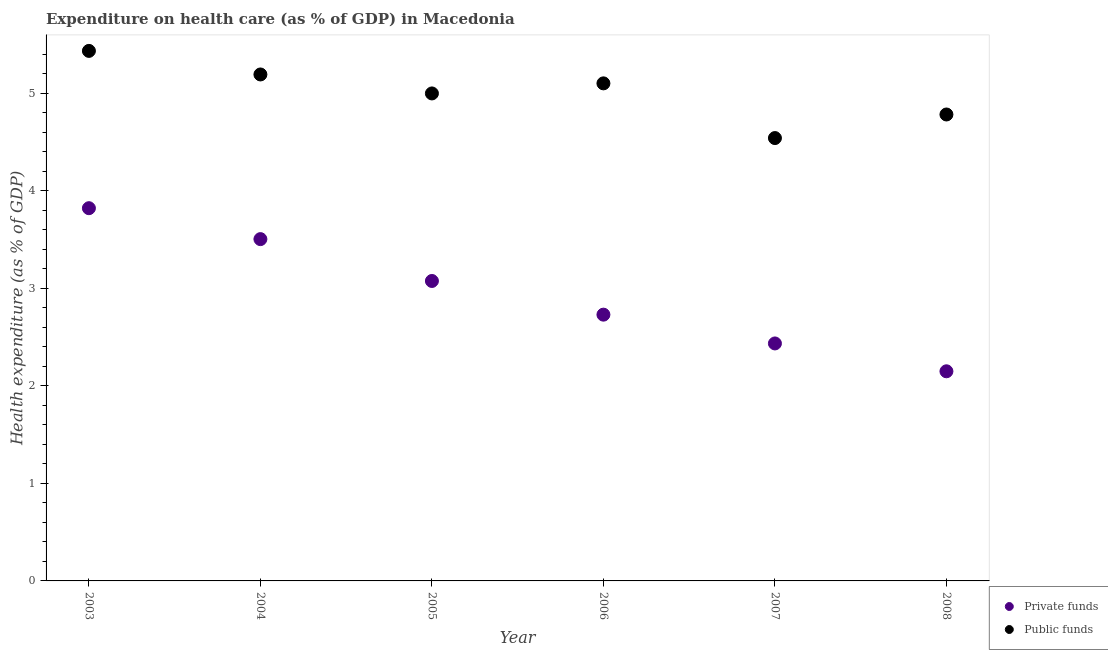Is the number of dotlines equal to the number of legend labels?
Keep it short and to the point. Yes. What is the amount of public funds spent in healthcare in 2003?
Your answer should be compact. 5.43. Across all years, what is the maximum amount of private funds spent in healthcare?
Your answer should be compact. 3.82. Across all years, what is the minimum amount of private funds spent in healthcare?
Your answer should be very brief. 2.15. What is the total amount of private funds spent in healthcare in the graph?
Your response must be concise. 17.72. What is the difference between the amount of public funds spent in healthcare in 2006 and that in 2008?
Offer a very short reply. 0.32. What is the difference between the amount of private funds spent in healthcare in 2003 and the amount of public funds spent in healthcare in 2005?
Your answer should be very brief. -1.18. What is the average amount of public funds spent in healthcare per year?
Give a very brief answer. 5.01. In the year 2003, what is the difference between the amount of private funds spent in healthcare and amount of public funds spent in healthcare?
Make the answer very short. -1.61. In how many years, is the amount of public funds spent in healthcare greater than 2.2 %?
Your answer should be compact. 6. What is the ratio of the amount of public funds spent in healthcare in 2003 to that in 2005?
Offer a very short reply. 1.09. Is the amount of private funds spent in healthcare in 2003 less than that in 2008?
Make the answer very short. No. Is the difference between the amount of private funds spent in healthcare in 2004 and 2005 greater than the difference between the amount of public funds spent in healthcare in 2004 and 2005?
Keep it short and to the point. Yes. What is the difference between the highest and the second highest amount of public funds spent in healthcare?
Give a very brief answer. 0.24. What is the difference between the highest and the lowest amount of private funds spent in healthcare?
Provide a short and direct response. 1.67. Is the amount of public funds spent in healthcare strictly greater than the amount of private funds spent in healthcare over the years?
Keep it short and to the point. Yes. What is the difference between two consecutive major ticks on the Y-axis?
Your answer should be compact. 1. Are the values on the major ticks of Y-axis written in scientific E-notation?
Make the answer very short. No. Does the graph contain any zero values?
Provide a short and direct response. No. How many legend labels are there?
Keep it short and to the point. 2. How are the legend labels stacked?
Your response must be concise. Vertical. What is the title of the graph?
Provide a succinct answer. Expenditure on health care (as % of GDP) in Macedonia. Does "Male labourers" appear as one of the legend labels in the graph?
Give a very brief answer. No. What is the label or title of the Y-axis?
Offer a terse response. Health expenditure (as % of GDP). What is the Health expenditure (as % of GDP) of Private funds in 2003?
Your answer should be very brief. 3.82. What is the Health expenditure (as % of GDP) in Public funds in 2003?
Provide a short and direct response. 5.43. What is the Health expenditure (as % of GDP) of Private funds in 2004?
Your response must be concise. 3.5. What is the Health expenditure (as % of GDP) in Public funds in 2004?
Offer a very short reply. 5.19. What is the Health expenditure (as % of GDP) of Private funds in 2005?
Offer a very short reply. 3.08. What is the Health expenditure (as % of GDP) of Public funds in 2005?
Offer a very short reply. 5. What is the Health expenditure (as % of GDP) in Private funds in 2006?
Provide a short and direct response. 2.73. What is the Health expenditure (as % of GDP) in Public funds in 2006?
Give a very brief answer. 5.1. What is the Health expenditure (as % of GDP) in Private funds in 2007?
Your response must be concise. 2.44. What is the Health expenditure (as % of GDP) in Public funds in 2007?
Make the answer very short. 4.54. What is the Health expenditure (as % of GDP) of Private funds in 2008?
Your answer should be very brief. 2.15. What is the Health expenditure (as % of GDP) in Public funds in 2008?
Your answer should be compact. 4.78. Across all years, what is the maximum Health expenditure (as % of GDP) in Private funds?
Your answer should be compact. 3.82. Across all years, what is the maximum Health expenditure (as % of GDP) in Public funds?
Ensure brevity in your answer.  5.43. Across all years, what is the minimum Health expenditure (as % of GDP) of Private funds?
Make the answer very short. 2.15. Across all years, what is the minimum Health expenditure (as % of GDP) in Public funds?
Give a very brief answer. 4.54. What is the total Health expenditure (as % of GDP) in Private funds in the graph?
Your answer should be very brief. 17.72. What is the total Health expenditure (as % of GDP) of Public funds in the graph?
Provide a succinct answer. 30.05. What is the difference between the Health expenditure (as % of GDP) of Private funds in 2003 and that in 2004?
Your answer should be very brief. 0.32. What is the difference between the Health expenditure (as % of GDP) of Public funds in 2003 and that in 2004?
Your answer should be compact. 0.24. What is the difference between the Health expenditure (as % of GDP) of Private funds in 2003 and that in 2005?
Offer a very short reply. 0.75. What is the difference between the Health expenditure (as % of GDP) in Public funds in 2003 and that in 2005?
Provide a succinct answer. 0.44. What is the difference between the Health expenditure (as % of GDP) of Private funds in 2003 and that in 2006?
Provide a short and direct response. 1.09. What is the difference between the Health expenditure (as % of GDP) in Public funds in 2003 and that in 2006?
Ensure brevity in your answer.  0.33. What is the difference between the Health expenditure (as % of GDP) in Private funds in 2003 and that in 2007?
Ensure brevity in your answer.  1.39. What is the difference between the Health expenditure (as % of GDP) of Public funds in 2003 and that in 2007?
Your answer should be very brief. 0.89. What is the difference between the Health expenditure (as % of GDP) in Private funds in 2003 and that in 2008?
Ensure brevity in your answer.  1.67. What is the difference between the Health expenditure (as % of GDP) in Public funds in 2003 and that in 2008?
Provide a short and direct response. 0.65. What is the difference between the Health expenditure (as % of GDP) of Private funds in 2004 and that in 2005?
Your answer should be very brief. 0.43. What is the difference between the Health expenditure (as % of GDP) in Public funds in 2004 and that in 2005?
Your answer should be very brief. 0.19. What is the difference between the Health expenditure (as % of GDP) in Private funds in 2004 and that in 2006?
Make the answer very short. 0.77. What is the difference between the Health expenditure (as % of GDP) in Public funds in 2004 and that in 2006?
Provide a succinct answer. 0.09. What is the difference between the Health expenditure (as % of GDP) in Private funds in 2004 and that in 2007?
Your response must be concise. 1.07. What is the difference between the Health expenditure (as % of GDP) in Public funds in 2004 and that in 2007?
Ensure brevity in your answer.  0.65. What is the difference between the Health expenditure (as % of GDP) in Private funds in 2004 and that in 2008?
Offer a very short reply. 1.36. What is the difference between the Health expenditure (as % of GDP) in Public funds in 2004 and that in 2008?
Offer a terse response. 0.41. What is the difference between the Health expenditure (as % of GDP) in Private funds in 2005 and that in 2006?
Your response must be concise. 0.35. What is the difference between the Health expenditure (as % of GDP) of Public funds in 2005 and that in 2006?
Offer a very short reply. -0.1. What is the difference between the Health expenditure (as % of GDP) in Private funds in 2005 and that in 2007?
Provide a short and direct response. 0.64. What is the difference between the Health expenditure (as % of GDP) in Public funds in 2005 and that in 2007?
Your answer should be compact. 0.46. What is the difference between the Health expenditure (as % of GDP) of Private funds in 2005 and that in 2008?
Offer a very short reply. 0.93. What is the difference between the Health expenditure (as % of GDP) in Public funds in 2005 and that in 2008?
Your response must be concise. 0.22. What is the difference between the Health expenditure (as % of GDP) of Private funds in 2006 and that in 2007?
Your answer should be compact. 0.3. What is the difference between the Health expenditure (as % of GDP) in Public funds in 2006 and that in 2007?
Offer a terse response. 0.56. What is the difference between the Health expenditure (as % of GDP) of Private funds in 2006 and that in 2008?
Keep it short and to the point. 0.58. What is the difference between the Health expenditure (as % of GDP) in Public funds in 2006 and that in 2008?
Provide a succinct answer. 0.32. What is the difference between the Health expenditure (as % of GDP) in Private funds in 2007 and that in 2008?
Provide a succinct answer. 0.29. What is the difference between the Health expenditure (as % of GDP) in Public funds in 2007 and that in 2008?
Keep it short and to the point. -0.24. What is the difference between the Health expenditure (as % of GDP) in Private funds in 2003 and the Health expenditure (as % of GDP) in Public funds in 2004?
Give a very brief answer. -1.37. What is the difference between the Health expenditure (as % of GDP) of Private funds in 2003 and the Health expenditure (as % of GDP) of Public funds in 2005?
Your answer should be very brief. -1.18. What is the difference between the Health expenditure (as % of GDP) in Private funds in 2003 and the Health expenditure (as % of GDP) in Public funds in 2006?
Give a very brief answer. -1.28. What is the difference between the Health expenditure (as % of GDP) in Private funds in 2003 and the Health expenditure (as % of GDP) in Public funds in 2007?
Provide a short and direct response. -0.72. What is the difference between the Health expenditure (as % of GDP) of Private funds in 2003 and the Health expenditure (as % of GDP) of Public funds in 2008?
Provide a succinct answer. -0.96. What is the difference between the Health expenditure (as % of GDP) in Private funds in 2004 and the Health expenditure (as % of GDP) in Public funds in 2005?
Offer a terse response. -1.49. What is the difference between the Health expenditure (as % of GDP) of Private funds in 2004 and the Health expenditure (as % of GDP) of Public funds in 2006?
Your response must be concise. -1.6. What is the difference between the Health expenditure (as % of GDP) of Private funds in 2004 and the Health expenditure (as % of GDP) of Public funds in 2007?
Make the answer very short. -1.04. What is the difference between the Health expenditure (as % of GDP) of Private funds in 2004 and the Health expenditure (as % of GDP) of Public funds in 2008?
Make the answer very short. -1.28. What is the difference between the Health expenditure (as % of GDP) of Private funds in 2005 and the Health expenditure (as % of GDP) of Public funds in 2006?
Ensure brevity in your answer.  -2.03. What is the difference between the Health expenditure (as % of GDP) of Private funds in 2005 and the Health expenditure (as % of GDP) of Public funds in 2007?
Ensure brevity in your answer.  -1.47. What is the difference between the Health expenditure (as % of GDP) in Private funds in 2005 and the Health expenditure (as % of GDP) in Public funds in 2008?
Provide a short and direct response. -1.71. What is the difference between the Health expenditure (as % of GDP) of Private funds in 2006 and the Health expenditure (as % of GDP) of Public funds in 2007?
Your answer should be very brief. -1.81. What is the difference between the Health expenditure (as % of GDP) of Private funds in 2006 and the Health expenditure (as % of GDP) of Public funds in 2008?
Make the answer very short. -2.05. What is the difference between the Health expenditure (as % of GDP) in Private funds in 2007 and the Health expenditure (as % of GDP) in Public funds in 2008?
Keep it short and to the point. -2.35. What is the average Health expenditure (as % of GDP) in Private funds per year?
Offer a terse response. 2.95. What is the average Health expenditure (as % of GDP) of Public funds per year?
Offer a terse response. 5.01. In the year 2003, what is the difference between the Health expenditure (as % of GDP) of Private funds and Health expenditure (as % of GDP) of Public funds?
Provide a short and direct response. -1.61. In the year 2004, what is the difference between the Health expenditure (as % of GDP) in Private funds and Health expenditure (as % of GDP) in Public funds?
Your answer should be compact. -1.69. In the year 2005, what is the difference between the Health expenditure (as % of GDP) of Private funds and Health expenditure (as % of GDP) of Public funds?
Offer a very short reply. -1.92. In the year 2006, what is the difference between the Health expenditure (as % of GDP) of Private funds and Health expenditure (as % of GDP) of Public funds?
Your response must be concise. -2.37. In the year 2007, what is the difference between the Health expenditure (as % of GDP) in Private funds and Health expenditure (as % of GDP) in Public funds?
Ensure brevity in your answer.  -2.11. In the year 2008, what is the difference between the Health expenditure (as % of GDP) in Private funds and Health expenditure (as % of GDP) in Public funds?
Your response must be concise. -2.63. What is the ratio of the Health expenditure (as % of GDP) in Private funds in 2003 to that in 2004?
Provide a succinct answer. 1.09. What is the ratio of the Health expenditure (as % of GDP) of Public funds in 2003 to that in 2004?
Your response must be concise. 1.05. What is the ratio of the Health expenditure (as % of GDP) of Private funds in 2003 to that in 2005?
Offer a very short reply. 1.24. What is the ratio of the Health expenditure (as % of GDP) of Public funds in 2003 to that in 2005?
Offer a terse response. 1.09. What is the ratio of the Health expenditure (as % of GDP) in Private funds in 2003 to that in 2006?
Give a very brief answer. 1.4. What is the ratio of the Health expenditure (as % of GDP) in Public funds in 2003 to that in 2006?
Give a very brief answer. 1.07. What is the ratio of the Health expenditure (as % of GDP) of Private funds in 2003 to that in 2007?
Your answer should be very brief. 1.57. What is the ratio of the Health expenditure (as % of GDP) in Public funds in 2003 to that in 2007?
Provide a short and direct response. 1.2. What is the ratio of the Health expenditure (as % of GDP) in Private funds in 2003 to that in 2008?
Provide a succinct answer. 1.78. What is the ratio of the Health expenditure (as % of GDP) in Public funds in 2003 to that in 2008?
Your answer should be compact. 1.14. What is the ratio of the Health expenditure (as % of GDP) of Private funds in 2004 to that in 2005?
Keep it short and to the point. 1.14. What is the ratio of the Health expenditure (as % of GDP) in Public funds in 2004 to that in 2005?
Your answer should be compact. 1.04. What is the ratio of the Health expenditure (as % of GDP) in Private funds in 2004 to that in 2006?
Offer a very short reply. 1.28. What is the ratio of the Health expenditure (as % of GDP) of Public funds in 2004 to that in 2006?
Make the answer very short. 1.02. What is the ratio of the Health expenditure (as % of GDP) of Private funds in 2004 to that in 2007?
Your answer should be compact. 1.44. What is the ratio of the Health expenditure (as % of GDP) of Public funds in 2004 to that in 2007?
Keep it short and to the point. 1.14. What is the ratio of the Health expenditure (as % of GDP) in Private funds in 2004 to that in 2008?
Offer a terse response. 1.63. What is the ratio of the Health expenditure (as % of GDP) of Public funds in 2004 to that in 2008?
Your answer should be compact. 1.09. What is the ratio of the Health expenditure (as % of GDP) of Private funds in 2005 to that in 2006?
Offer a very short reply. 1.13. What is the ratio of the Health expenditure (as % of GDP) in Public funds in 2005 to that in 2006?
Make the answer very short. 0.98. What is the ratio of the Health expenditure (as % of GDP) in Private funds in 2005 to that in 2007?
Your answer should be very brief. 1.26. What is the ratio of the Health expenditure (as % of GDP) of Public funds in 2005 to that in 2007?
Offer a terse response. 1.1. What is the ratio of the Health expenditure (as % of GDP) in Private funds in 2005 to that in 2008?
Offer a very short reply. 1.43. What is the ratio of the Health expenditure (as % of GDP) in Public funds in 2005 to that in 2008?
Provide a short and direct response. 1.05. What is the ratio of the Health expenditure (as % of GDP) of Private funds in 2006 to that in 2007?
Provide a succinct answer. 1.12. What is the ratio of the Health expenditure (as % of GDP) of Public funds in 2006 to that in 2007?
Your answer should be very brief. 1.12. What is the ratio of the Health expenditure (as % of GDP) of Private funds in 2006 to that in 2008?
Offer a very short reply. 1.27. What is the ratio of the Health expenditure (as % of GDP) in Public funds in 2006 to that in 2008?
Your answer should be very brief. 1.07. What is the ratio of the Health expenditure (as % of GDP) in Private funds in 2007 to that in 2008?
Your answer should be compact. 1.13. What is the ratio of the Health expenditure (as % of GDP) of Public funds in 2007 to that in 2008?
Offer a terse response. 0.95. What is the difference between the highest and the second highest Health expenditure (as % of GDP) in Private funds?
Keep it short and to the point. 0.32. What is the difference between the highest and the second highest Health expenditure (as % of GDP) in Public funds?
Ensure brevity in your answer.  0.24. What is the difference between the highest and the lowest Health expenditure (as % of GDP) in Private funds?
Make the answer very short. 1.67. What is the difference between the highest and the lowest Health expenditure (as % of GDP) of Public funds?
Your answer should be compact. 0.89. 